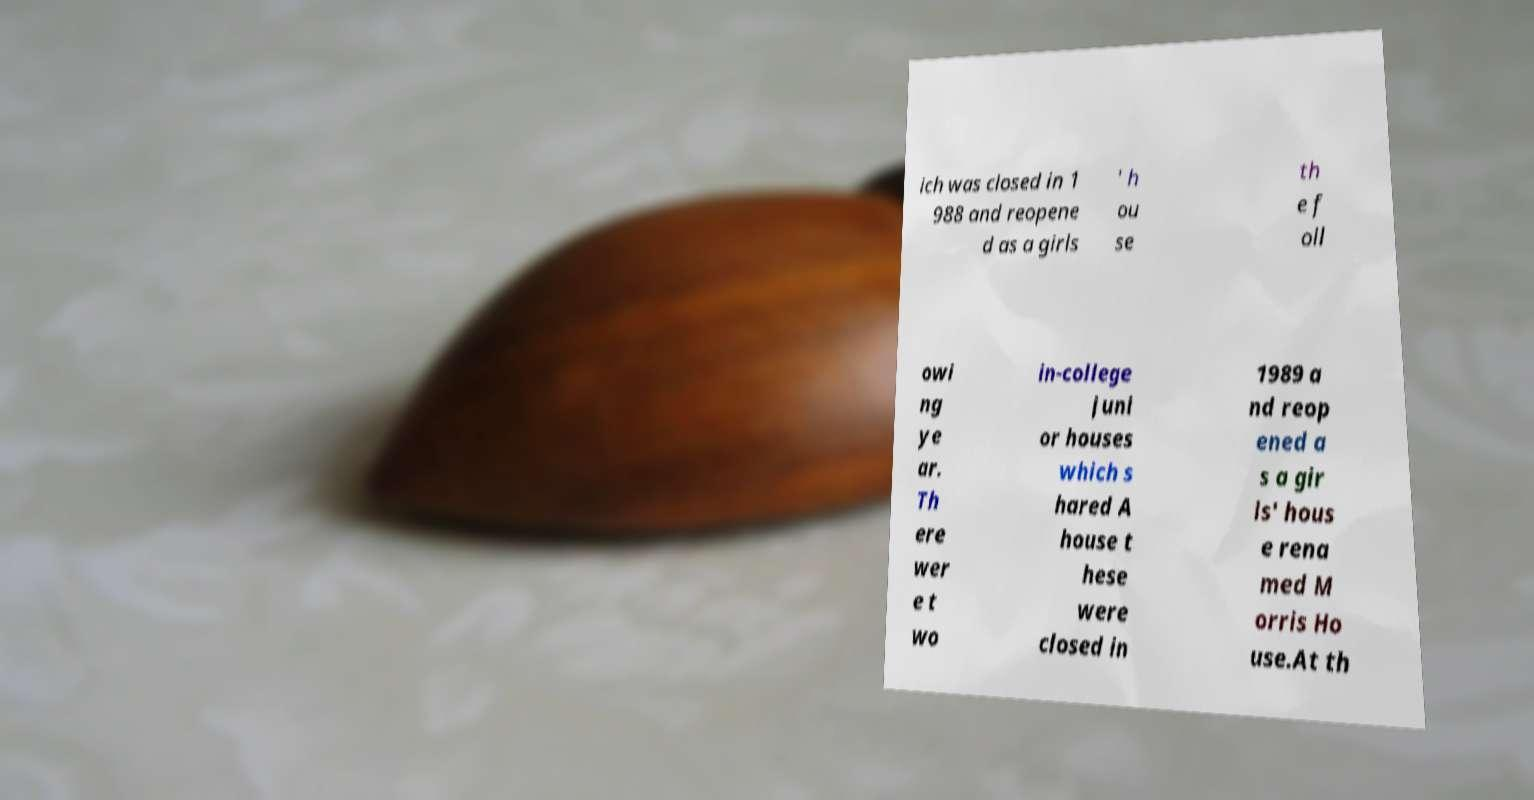For documentation purposes, I need the text within this image transcribed. Could you provide that? ich was closed in 1 988 and reopene d as a girls ' h ou se th e f oll owi ng ye ar. Th ere wer e t wo in-college juni or houses which s hared A house t hese were closed in 1989 a nd reop ened a s a gir ls' hous e rena med M orris Ho use.At th 